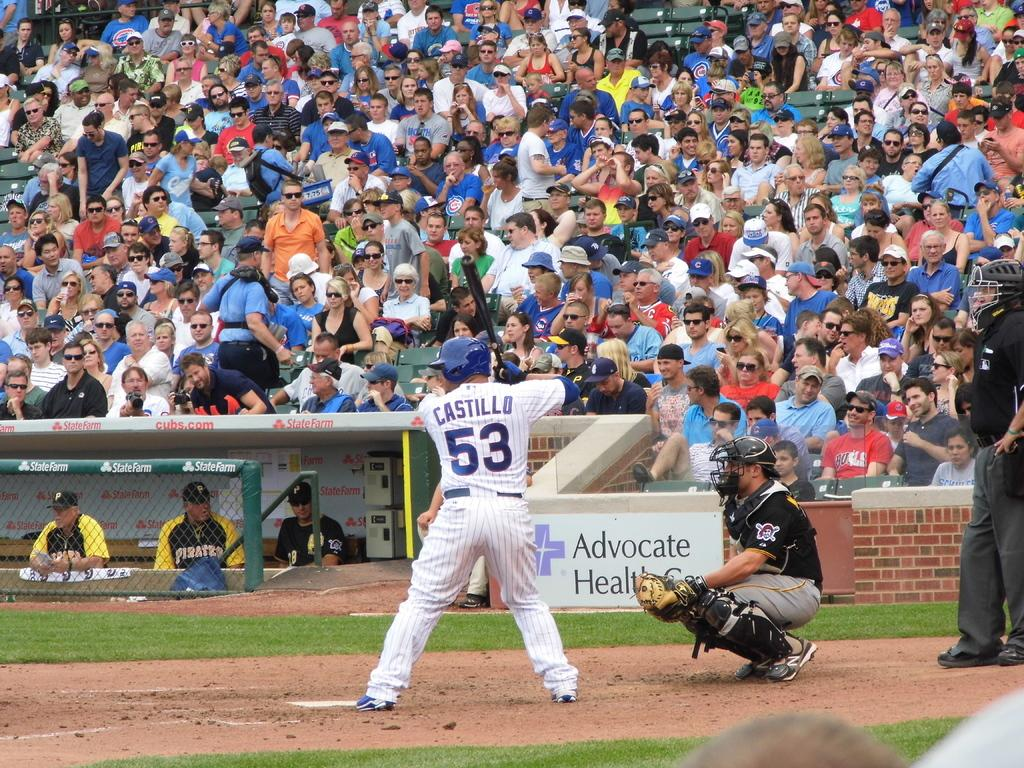<image>
Describe the image concisely. Castillo is at bat, and he holds his bat up in position for taking a swing. 